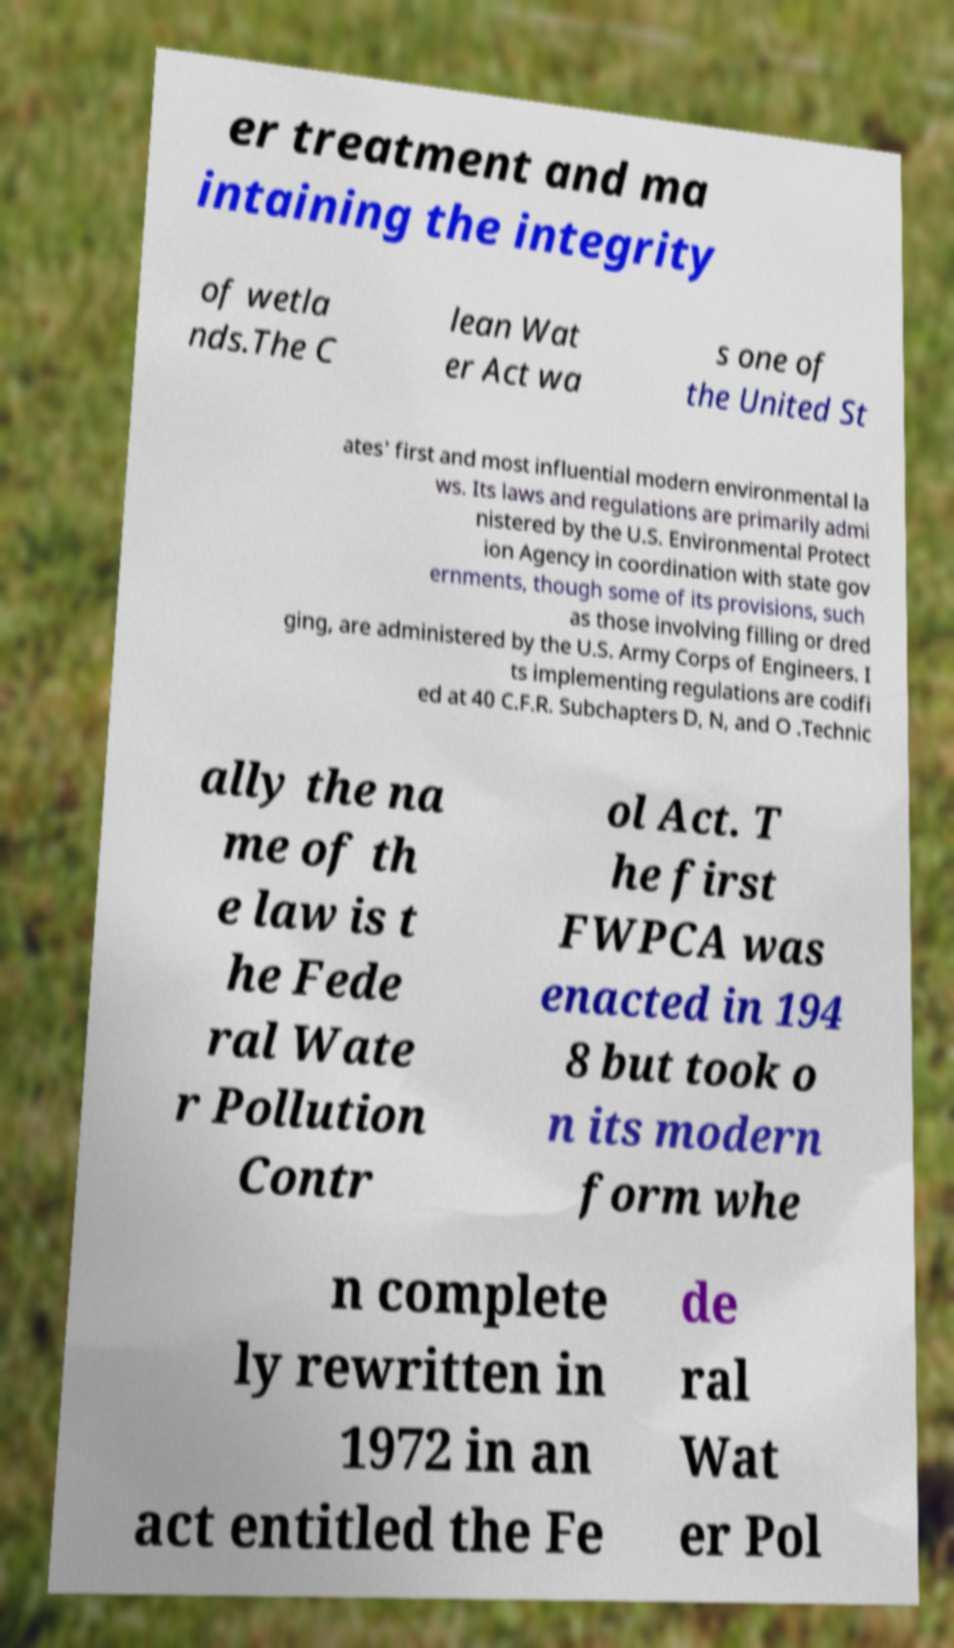What messages or text are displayed in this image? I need them in a readable, typed format. er treatment and ma intaining the integrity of wetla nds.The C lean Wat er Act wa s one of the United St ates' first and most influential modern environmental la ws. Its laws and regulations are primarily admi nistered by the U.S. Environmental Protect ion Agency in coordination with state gov ernments, though some of its provisions, such as those involving filling or dred ging, are administered by the U.S. Army Corps of Engineers. I ts implementing regulations are codifi ed at 40 C.F.R. Subchapters D, N, and O .Technic ally the na me of th e law is t he Fede ral Wate r Pollution Contr ol Act. T he first FWPCA was enacted in 194 8 but took o n its modern form whe n complete ly rewritten in 1972 in an act entitled the Fe de ral Wat er Pol 